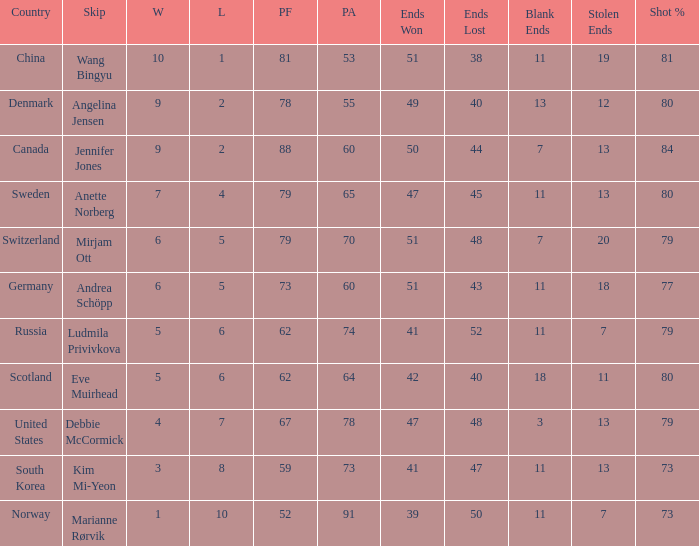Andrea schöpp serves as the skip for which country? Germany. 